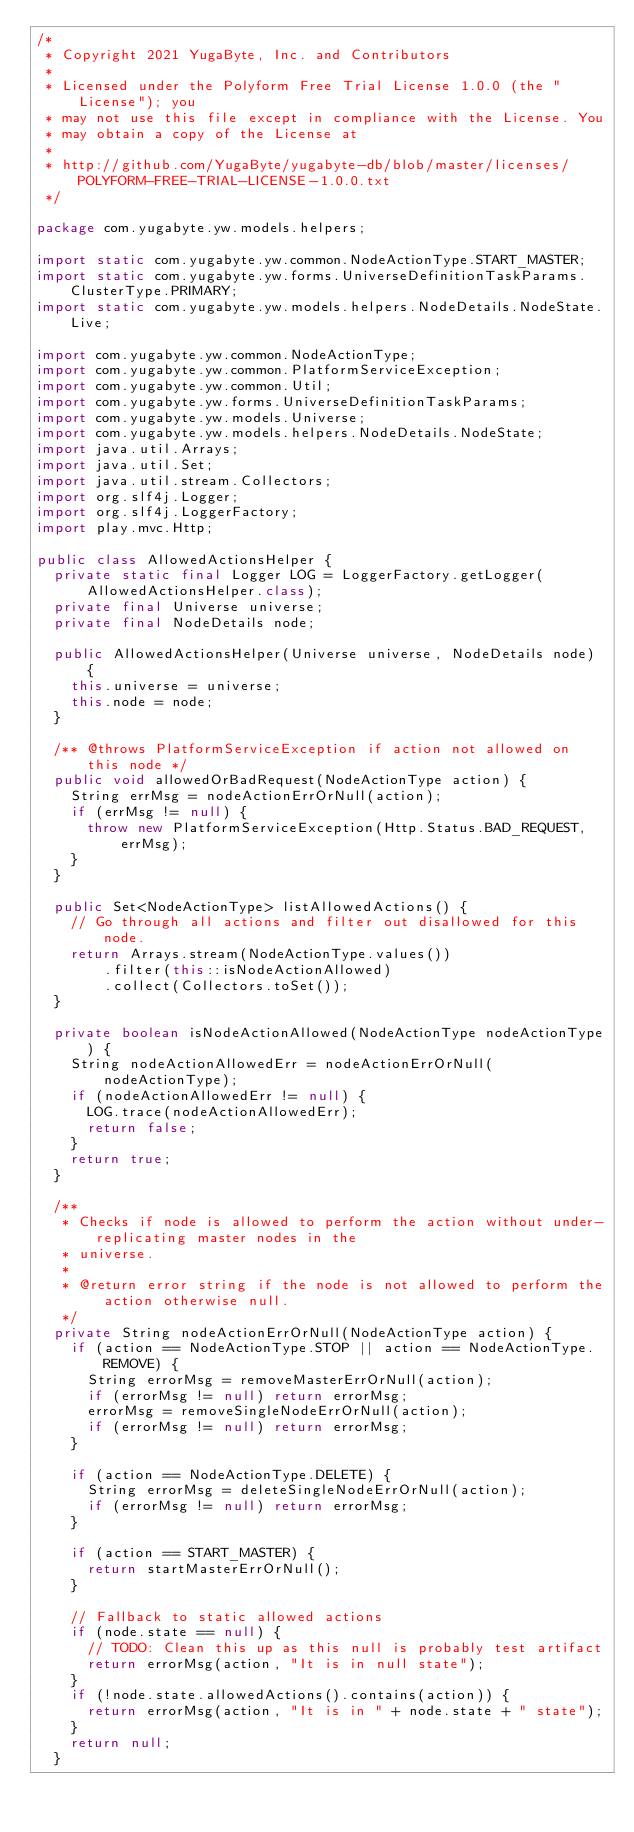Convert code to text. <code><loc_0><loc_0><loc_500><loc_500><_Java_>/*
 * Copyright 2021 YugaByte, Inc. and Contributors
 *
 * Licensed under the Polyform Free Trial License 1.0.0 (the "License"); you
 * may not use this file except in compliance with the License. You
 * may obtain a copy of the License at
 *
 * http://github.com/YugaByte/yugabyte-db/blob/master/licenses/POLYFORM-FREE-TRIAL-LICENSE-1.0.0.txt
 */

package com.yugabyte.yw.models.helpers;

import static com.yugabyte.yw.common.NodeActionType.START_MASTER;
import static com.yugabyte.yw.forms.UniverseDefinitionTaskParams.ClusterType.PRIMARY;
import static com.yugabyte.yw.models.helpers.NodeDetails.NodeState.Live;

import com.yugabyte.yw.common.NodeActionType;
import com.yugabyte.yw.common.PlatformServiceException;
import com.yugabyte.yw.common.Util;
import com.yugabyte.yw.forms.UniverseDefinitionTaskParams;
import com.yugabyte.yw.models.Universe;
import com.yugabyte.yw.models.helpers.NodeDetails.NodeState;
import java.util.Arrays;
import java.util.Set;
import java.util.stream.Collectors;
import org.slf4j.Logger;
import org.slf4j.LoggerFactory;
import play.mvc.Http;

public class AllowedActionsHelper {
  private static final Logger LOG = LoggerFactory.getLogger(AllowedActionsHelper.class);
  private final Universe universe;
  private final NodeDetails node;

  public AllowedActionsHelper(Universe universe, NodeDetails node) {
    this.universe = universe;
    this.node = node;
  }

  /** @throws PlatformServiceException if action not allowed on this node */
  public void allowedOrBadRequest(NodeActionType action) {
    String errMsg = nodeActionErrOrNull(action);
    if (errMsg != null) {
      throw new PlatformServiceException(Http.Status.BAD_REQUEST, errMsg);
    }
  }

  public Set<NodeActionType> listAllowedActions() {
    // Go through all actions and filter out disallowed for this node.
    return Arrays.stream(NodeActionType.values())
        .filter(this::isNodeActionAllowed)
        .collect(Collectors.toSet());
  }

  private boolean isNodeActionAllowed(NodeActionType nodeActionType) {
    String nodeActionAllowedErr = nodeActionErrOrNull(nodeActionType);
    if (nodeActionAllowedErr != null) {
      LOG.trace(nodeActionAllowedErr);
      return false;
    }
    return true;
  }

  /**
   * Checks if node is allowed to perform the action without under-replicating master nodes in the
   * universe.
   *
   * @return error string if the node is not allowed to perform the action otherwise null.
   */
  private String nodeActionErrOrNull(NodeActionType action) {
    if (action == NodeActionType.STOP || action == NodeActionType.REMOVE) {
      String errorMsg = removeMasterErrOrNull(action);
      if (errorMsg != null) return errorMsg;
      errorMsg = removeSingleNodeErrOrNull(action);
      if (errorMsg != null) return errorMsg;
    }

    if (action == NodeActionType.DELETE) {
      String errorMsg = deleteSingleNodeErrOrNull(action);
      if (errorMsg != null) return errorMsg;
    }

    if (action == START_MASTER) {
      return startMasterErrOrNull();
    }

    // Fallback to static allowed actions
    if (node.state == null) {
      // TODO: Clean this up as this null is probably test artifact
      return errorMsg(action, "It is in null state");
    }
    if (!node.state.allowedActions().contains(action)) {
      return errorMsg(action, "It is in " + node.state + " state");
    }
    return null;
  }
</code> 